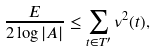<formula> <loc_0><loc_0><loc_500><loc_500>\frac { E } { 2 \log | A | } \leq \sum _ { t \in T ^ { \prime } } \nu ^ { 2 } ( t ) ,</formula> 